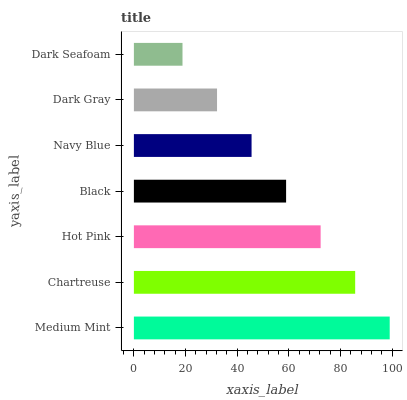Is Dark Seafoam the minimum?
Answer yes or no. Yes. Is Medium Mint the maximum?
Answer yes or no. Yes. Is Chartreuse the minimum?
Answer yes or no. No. Is Chartreuse the maximum?
Answer yes or no. No. Is Medium Mint greater than Chartreuse?
Answer yes or no. Yes. Is Chartreuse less than Medium Mint?
Answer yes or no. Yes. Is Chartreuse greater than Medium Mint?
Answer yes or no. No. Is Medium Mint less than Chartreuse?
Answer yes or no. No. Is Black the high median?
Answer yes or no. Yes. Is Black the low median?
Answer yes or no. Yes. Is Dark Gray the high median?
Answer yes or no. No. Is Hot Pink the low median?
Answer yes or no. No. 